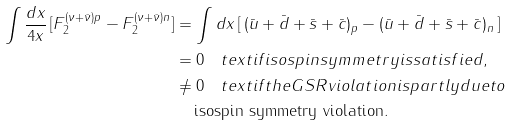Convert formula to latex. <formula><loc_0><loc_0><loc_500><loc_500>\int \frac { d x } { 4 x } \, [ F _ { 2 } ^ { ( \nu + \bar { \nu } ) p } - F _ { 2 } ^ { ( \nu + \bar { \nu } ) n } ] & = \int d x \, [ \, ( \bar { u } + \bar { d } + \bar { s } + \bar { c } ) _ { p } - ( \bar { u } + \bar { d } + \bar { s } + \bar { c } ) _ { n } \, ] \\ & = 0 \quad t e x t { i f i s o s p i n s y m m e t r y i s s a t i s f i e d } , \\ & \neq 0 \quad t e x t { i f t h e G S R v i o l a t i o n i s p a r t l y d u e t o } \\ & \quad \, \text {isospin symmetry violation} .</formula> 